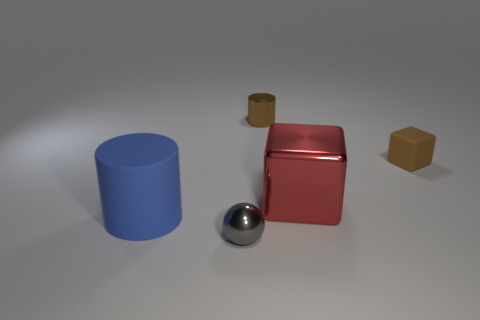Can you tell me what purpose this collection of objects might serve in a learning environment? These objects could be used in an educational context to teach various concepts, such as geometry and the properties of shapes, the physics of light and materials, or even principles of 3D modeling and rendering. 